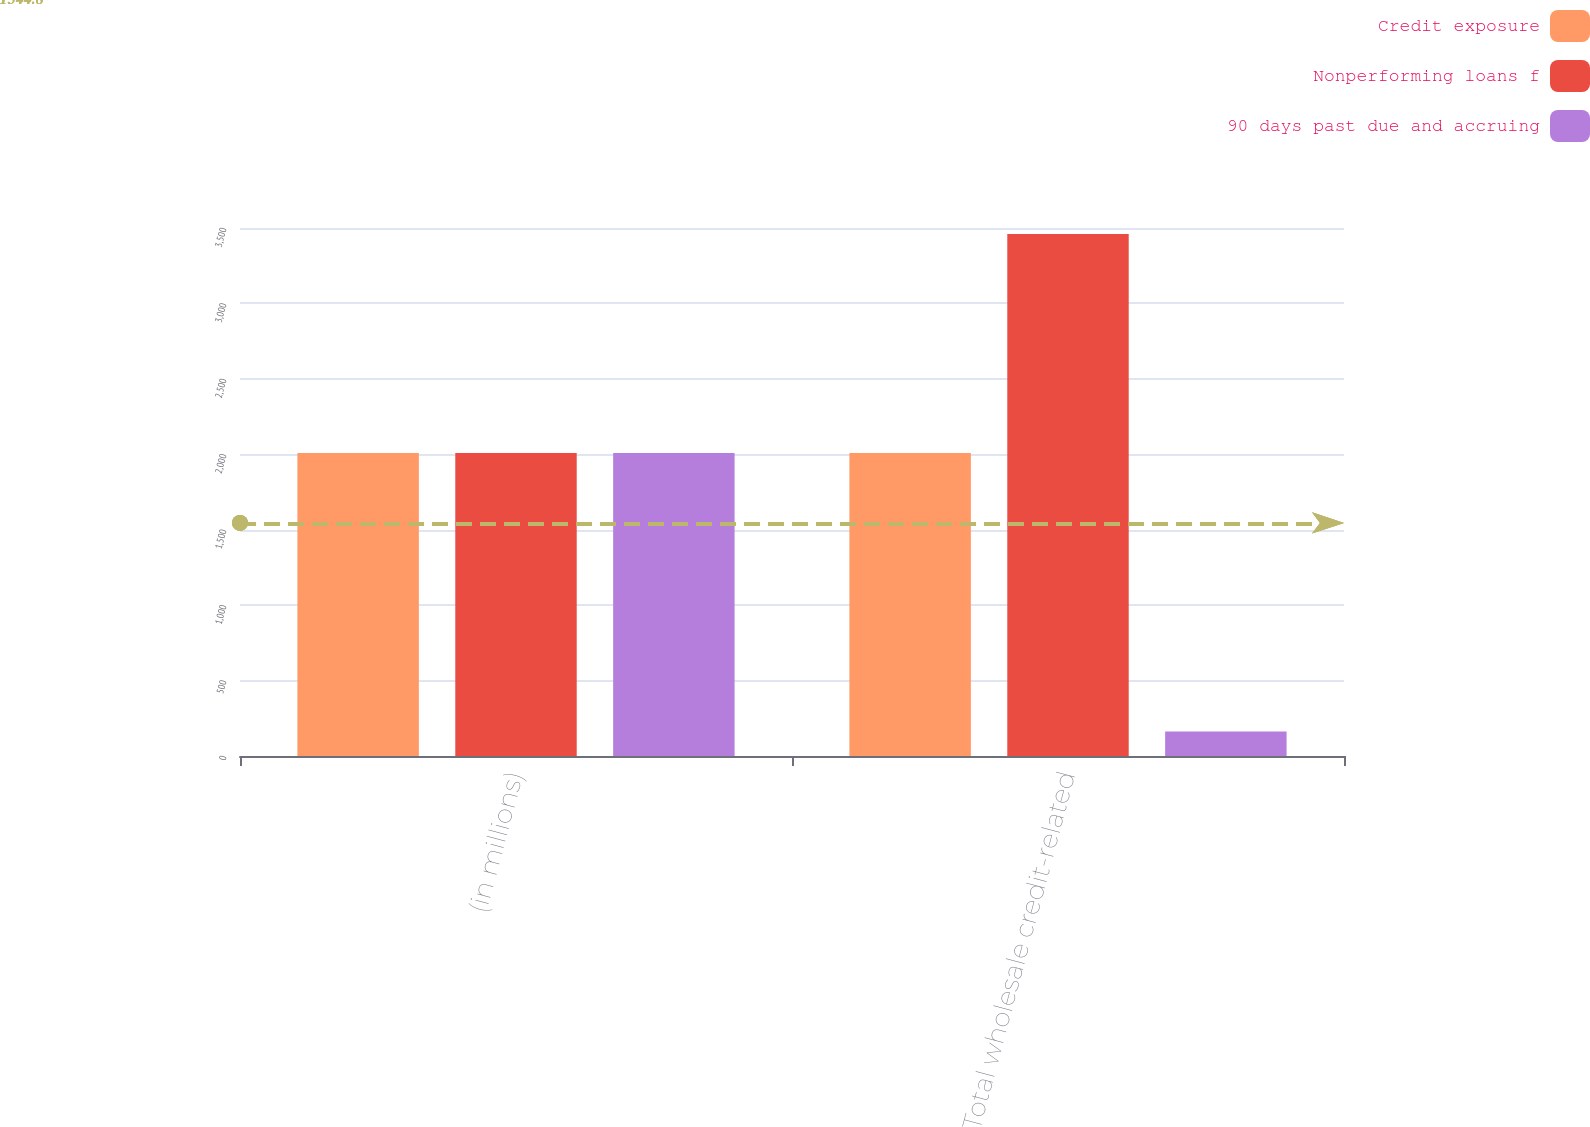<chart> <loc_0><loc_0><loc_500><loc_500><stacked_bar_chart><ecel><fcel>(in millions)<fcel>Total wholesale credit-related<nl><fcel>Credit exposure<fcel>2008<fcel>2008<nl><fcel>Nonperforming loans f<fcel>2008<fcel>3461<nl><fcel>90 days past due and accruing<fcel>2008<fcel>163<nl></chart> 